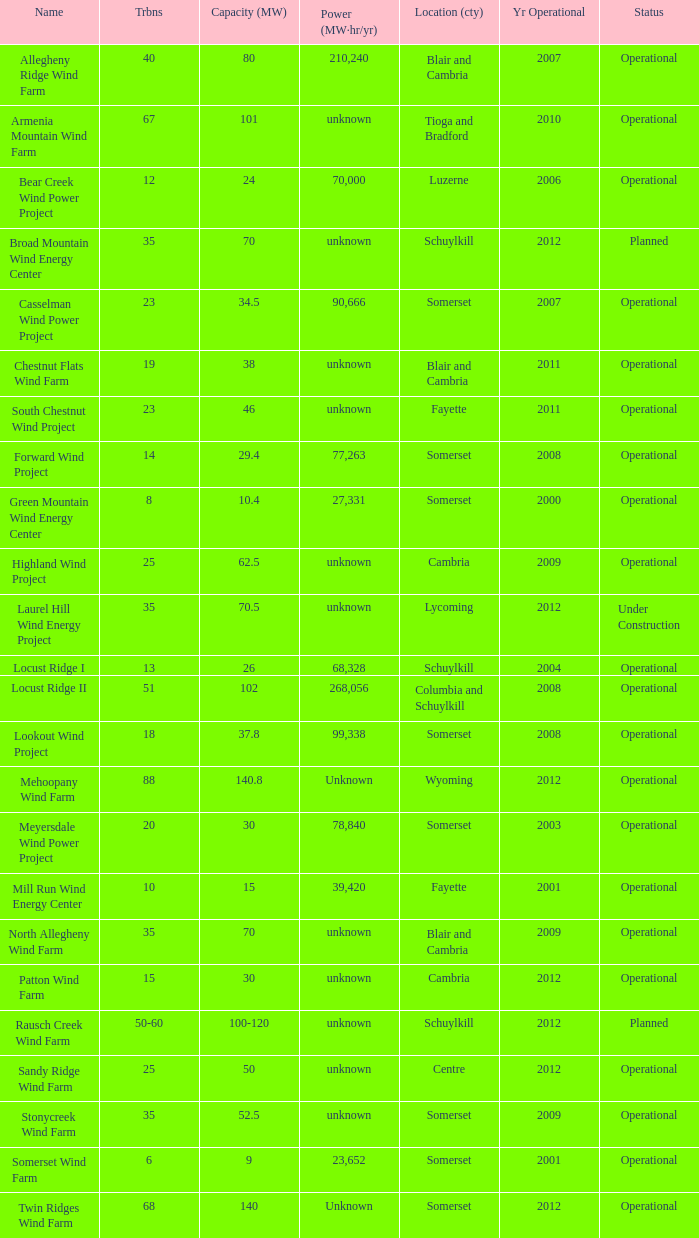What year was Fayette operational at 46? 2011.0. 